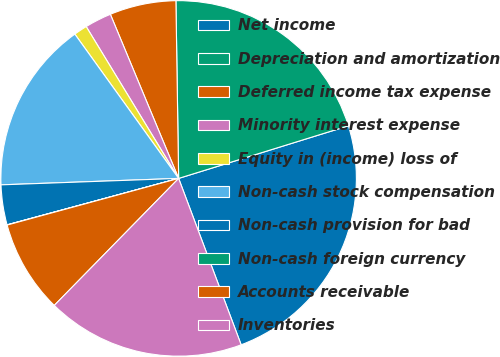<chart> <loc_0><loc_0><loc_500><loc_500><pie_chart><fcel>Net income<fcel>Depreciation and amortization<fcel>Deferred income tax expense<fcel>Minority interest expense<fcel>Equity in (income) loss of<fcel>Non-cash stock compensation<fcel>Non-cash provision for bad<fcel>Non-cash foreign currency<fcel>Accounts receivable<fcel>Inventories<nl><fcel>24.06%<fcel>20.46%<fcel>6.03%<fcel>2.43%<fcel>1.22%<fcel>15.65%<fcel>3.63%<fcel>0.02%<fcel>8.44%<fcel>18.05%<nl></chart> 